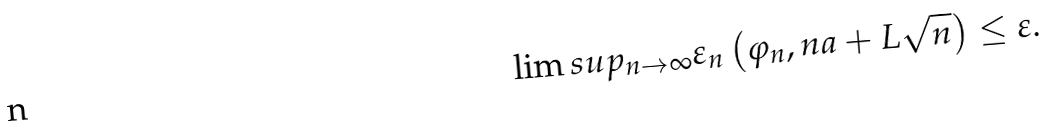Convert formula to latex. <formula><loc_0><loc_0><loc_500><loc_500>\lim s u p _ { n \rightarrow \infty } \varepsilon _ { n } \left ( \varphi _ { n } , n a + L \sqrt { n } \right ) \leq \varepsilon .</formula> 